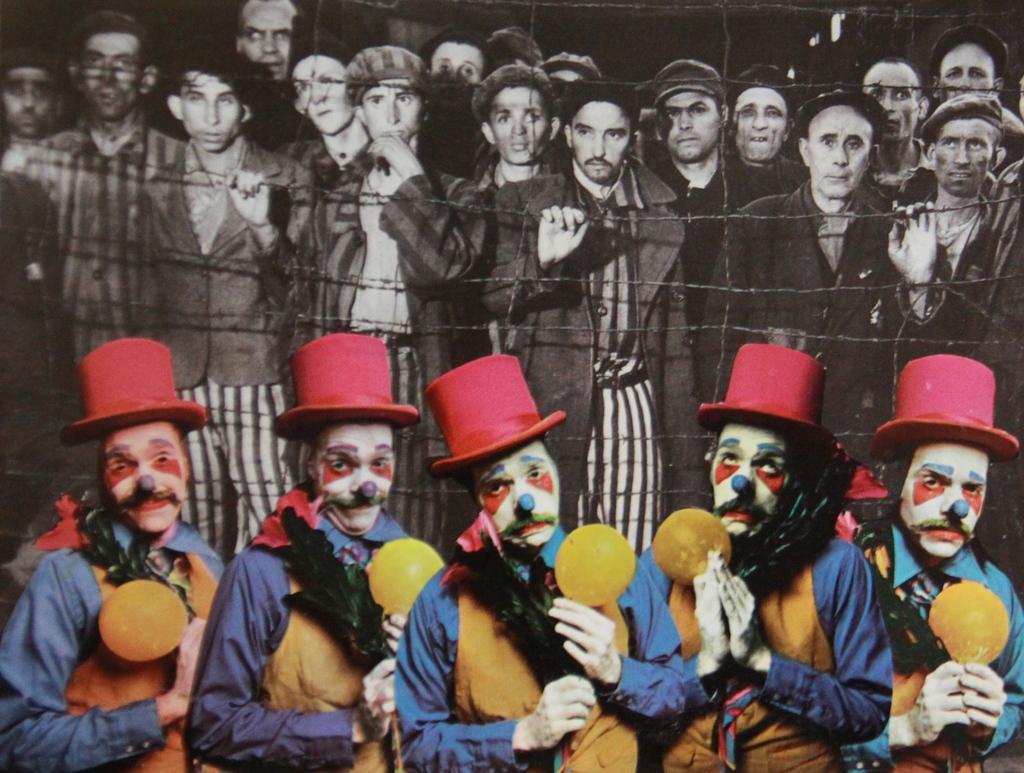Could you give a brief overview of what you see in this image? This is the edited image where there are few people standing behind the fence, there are few people in costumes and holding some objects. 